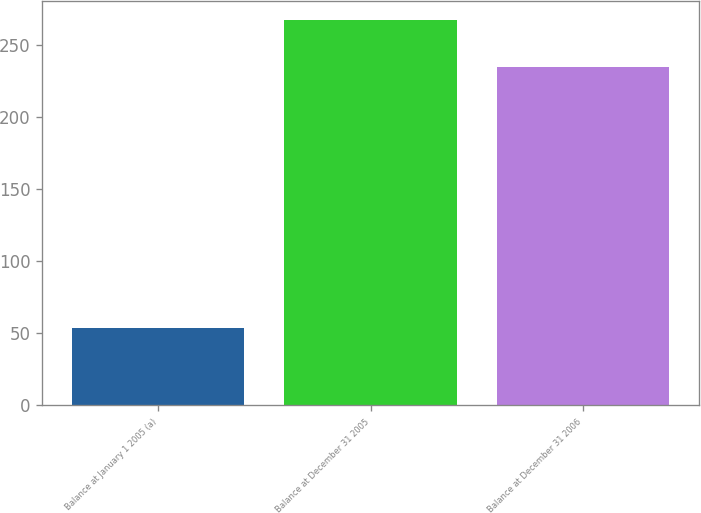<chart> <loc_0><loc_0><loc_500><loc_500><bar_chart><fcel>Balance at January 1 2005 (a)<fcel>Balance at December 31 2005<fcel>Balance at December 31 2006<nl><fcel>54<fcel>267<fcel>235<nl></chart> 